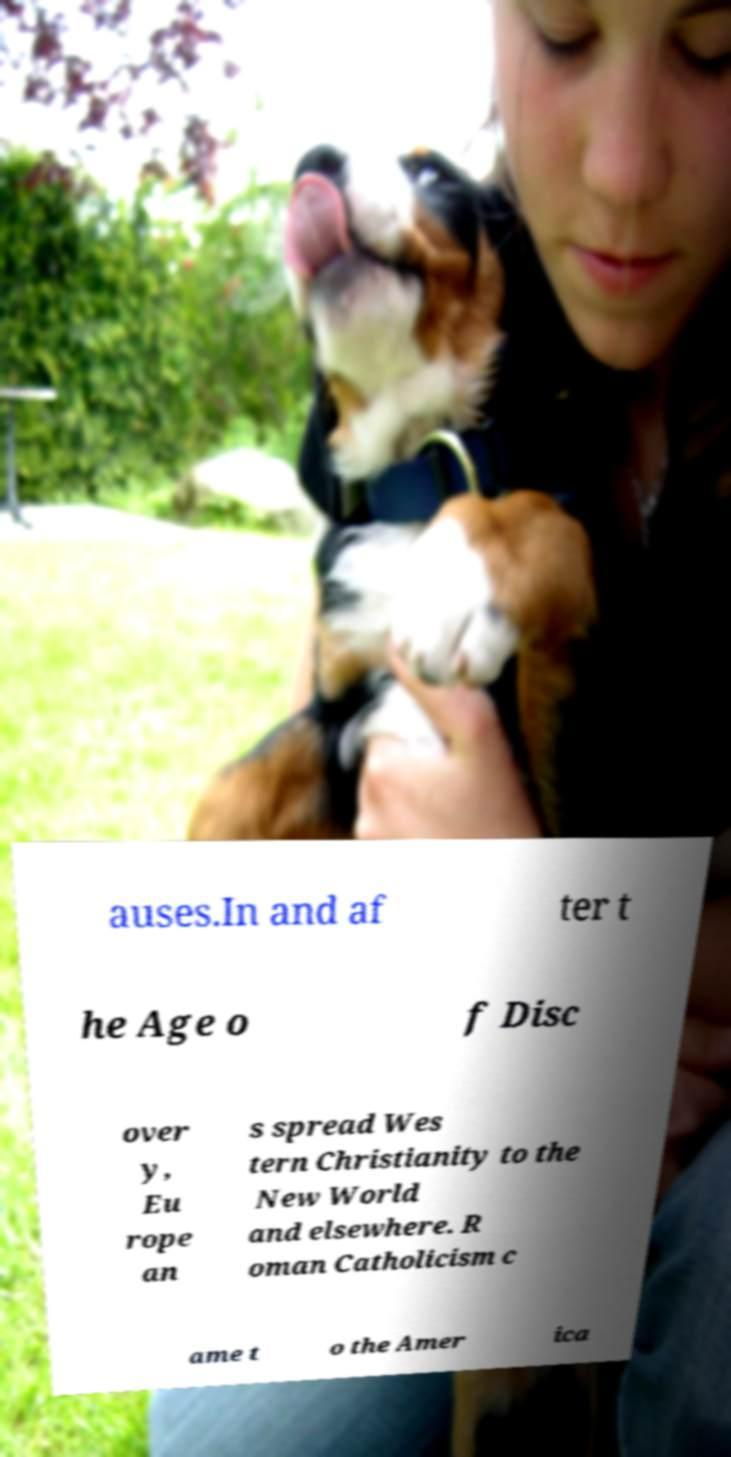Could you extract and type out the text from this image? auses.In and af ter t he Age o f Disc over y, Eu rope an s spread Wes tern Christianity to the New World and elsewhere. R oman Catholicism c ame t o the Amer ica 